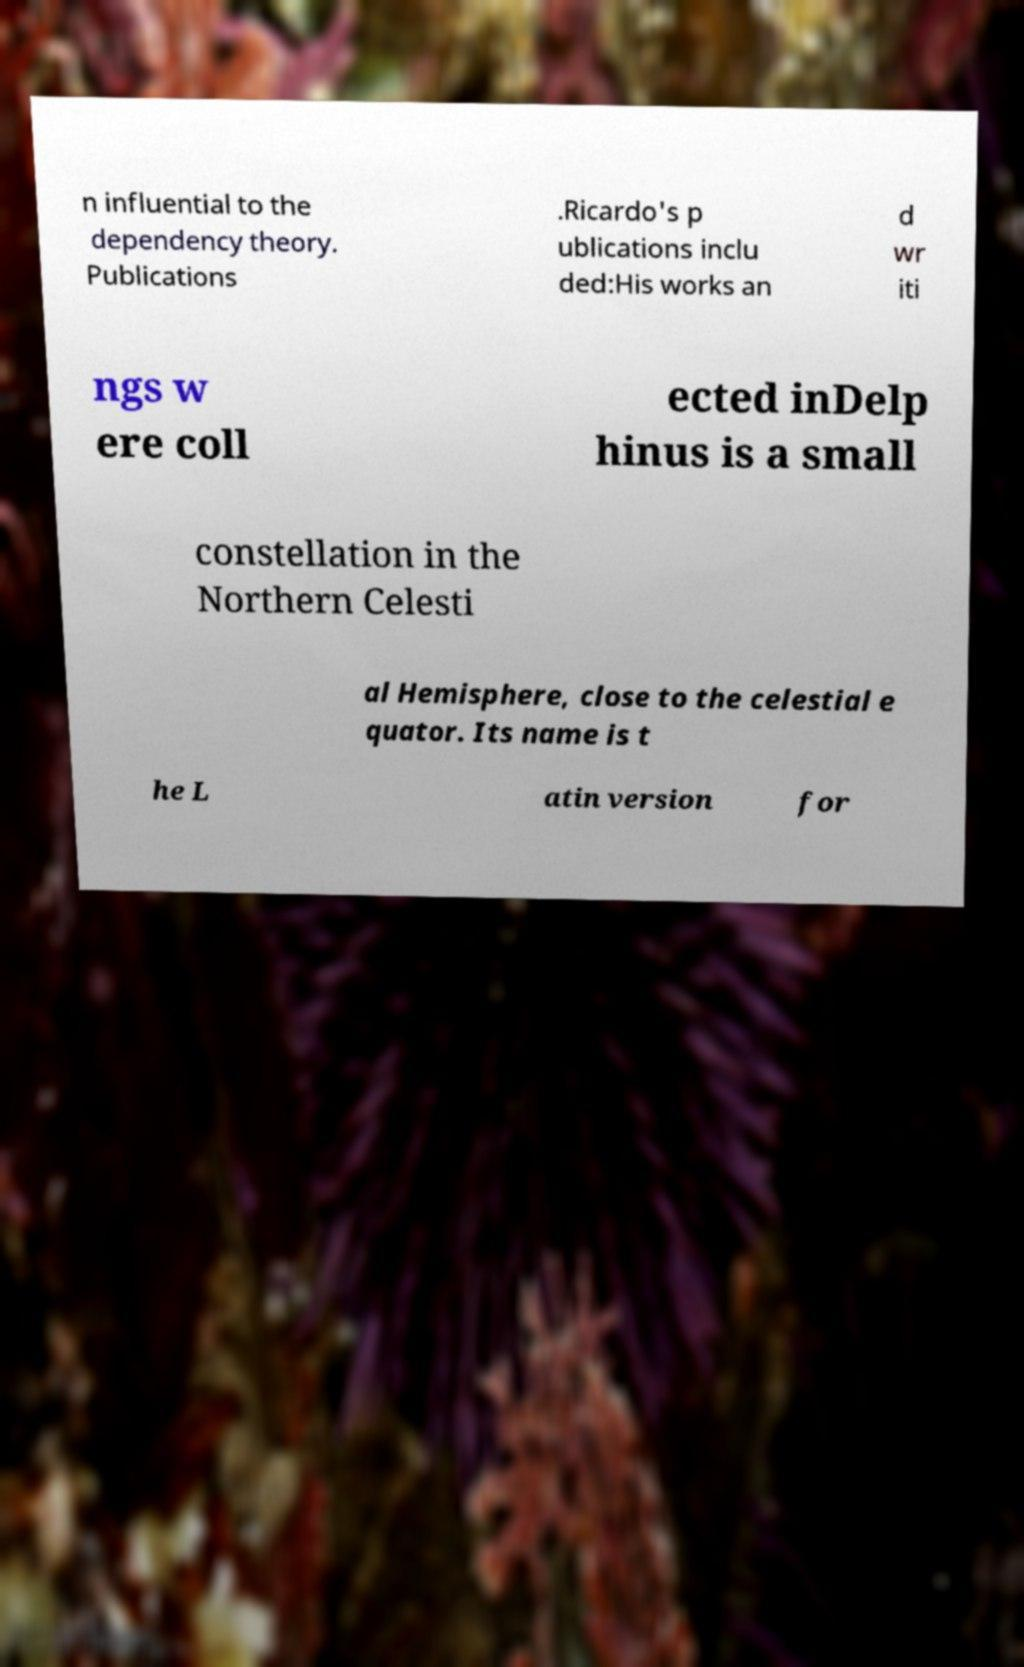I need the written content from this picture converted into text. Can you do that? n influential to the dependency theory. Publications .Ricardo's p ublications inclu ded:His works an d wr iti ngs w ere coll ected inDelp hinus is a small constellation in the Northern Celesti al Hemisphere, close to the celestial e quator. Its name is t he L atin version for 